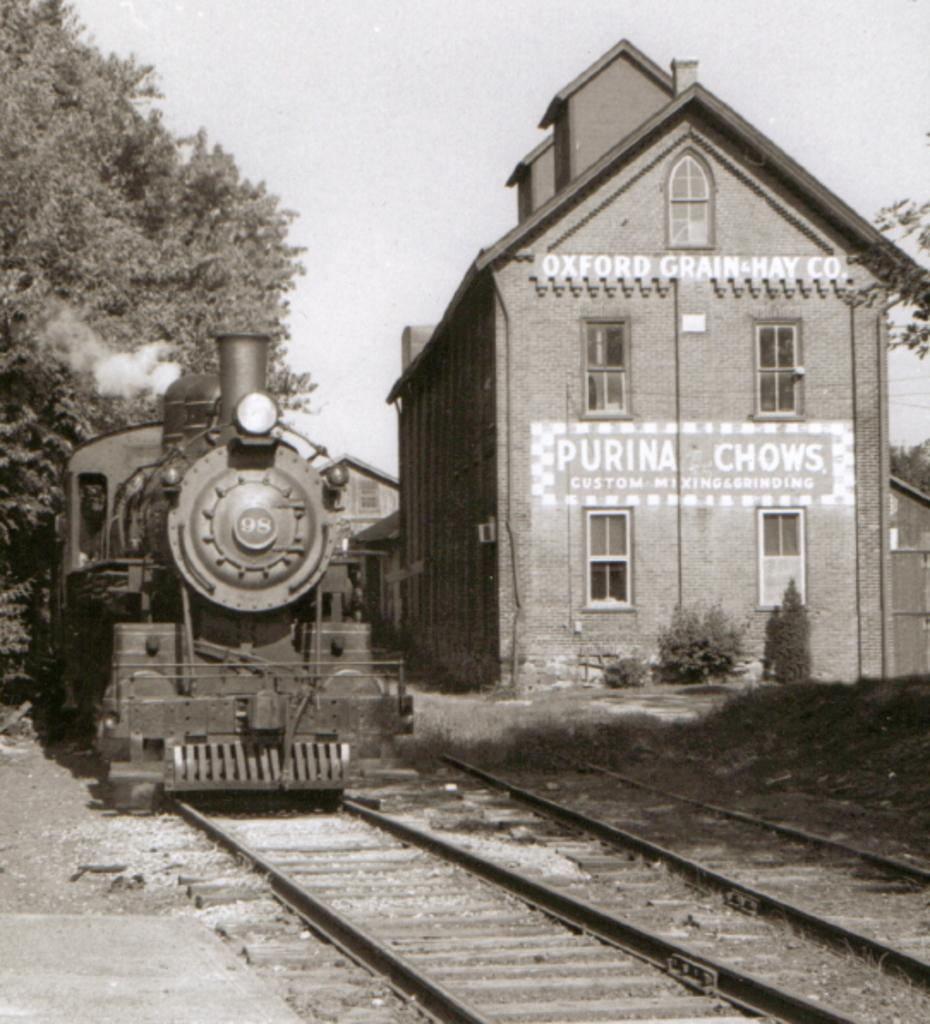What is the color scheme of the image? The image is black and white. What can be seen on the left side of the image? There is a train on the left side of the image. Where is the train located in the image? The train is on a railway track. What is visible on the right side of the image? There are buildings on the right side of the image. What can be seen in the background of the image? There are trees and the sky visible in the background of the image. Can you tell me how many people are swimming in the lake in the image? There is no lake present in the image, so it is not possible to determine how many people might be swimming in it. 